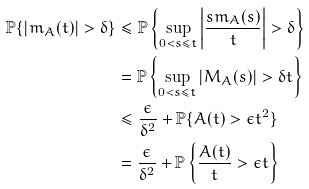<formula> <loc_0><loc_0><loc_500><loc_500>\mathbb { P } \{ | m _ { A } ( t ) | > \delta \} & \leq \mathbb { P } \left \{ \sup _ { 0 < s \leq t } \left | \frac { s m _ { A } ( s ) } { t } \right | > \delta \right \} \\ & = \mathbb { P } \left \{ \sup _ { 0 < s \leq t } \left | M _ { A } ( s ) \right | > \delta t \right \} \\ & \leq \frac { \epsilon } { \delta ^ { 2 } } + \mathbb { P } \{ A ( t ) > \epsilon t ^ { 2 } \} \\ & = \frac { \epsilon } { \delta ^ { 2 } } + \mathbb { P } \left \{ \frac { A ( t ) } { t } > \epsilon t \right \}</formula> 